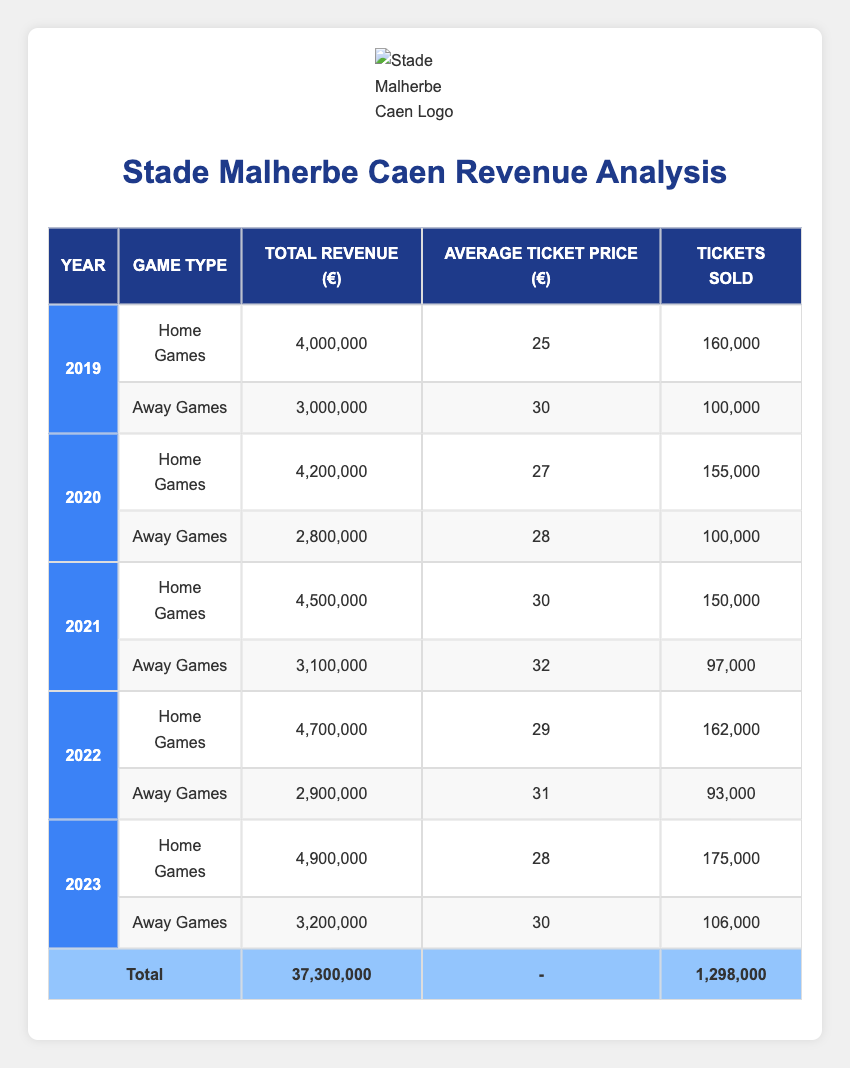What was the total revenue from home games in 2021? In 2021, the total revenue from home games is listed in the table as 4,500,000 euros.
Answer: 4,500,000 euros How many tickets were sold for away games in 2020? The number of tickets sold for away games in 2020 is stated in the table as 100,000.
Answer: 100,000 What is the average ticket price for home games across all five seasons? To calculate the average ticket price for home games, we sum the average prices: (25 + 27 + 30 + 29 + 28) = 139 euros. Then we divide by 5: 139/5 = 27.8 euros.
Answer: 27.8 euros Which year had the highest total revenue from away games? By comparing the total revenues for away games across all five years, 2023 shows the highest total revenue of 3,200,000 euros.
Answer: 2023 Is the average ticket price for home games in 2019 higher than that for away games in 2022? The average ticket price for home games in 2019 is 25 euros, while for away games in 2022, it is 31 euros. Since 25 is less than 31, the statement is false.
Answer: No What was the total revenue from home and away games combined in 2022? To calculate the total revenue in 2022, we add the total revenue from home games (4,700,000 euros) to the total revenue from away games (2,900,000 euros): 4,700,000 + 2,900,000 = 7,600,000 euros.
Answer: 7,600,000 euros Did Stade Malherbe Caen make more money from home games than away games in 2020? In 2020, the total revenue from home games was 4,200,000 euros while from away games it was 2,800,000 euros. Since 4,200,000 is greater than 2,800,000, the answer is yes.
Answer: Yes What is the difference in total revenue from home games between 2019 and 2023? The total revenue from home games in 2019 is 4,000,000 euros and in 2023 is 4,900,000 euros. The difference is calculated as 4,900,000 - 4,000,000 = 900,000 euros.
Answer: 900,000 euros What was the total number of tickets sold for away games over the five seasons? To find the total tickets sold for away games from 2019 to 2023, we sum the number of tickets sold each season: 100,000 + 100,000 + 97,000 + 93,000 + 106,000 = 496,000 tickets.
Answer: 496,000 tickets 